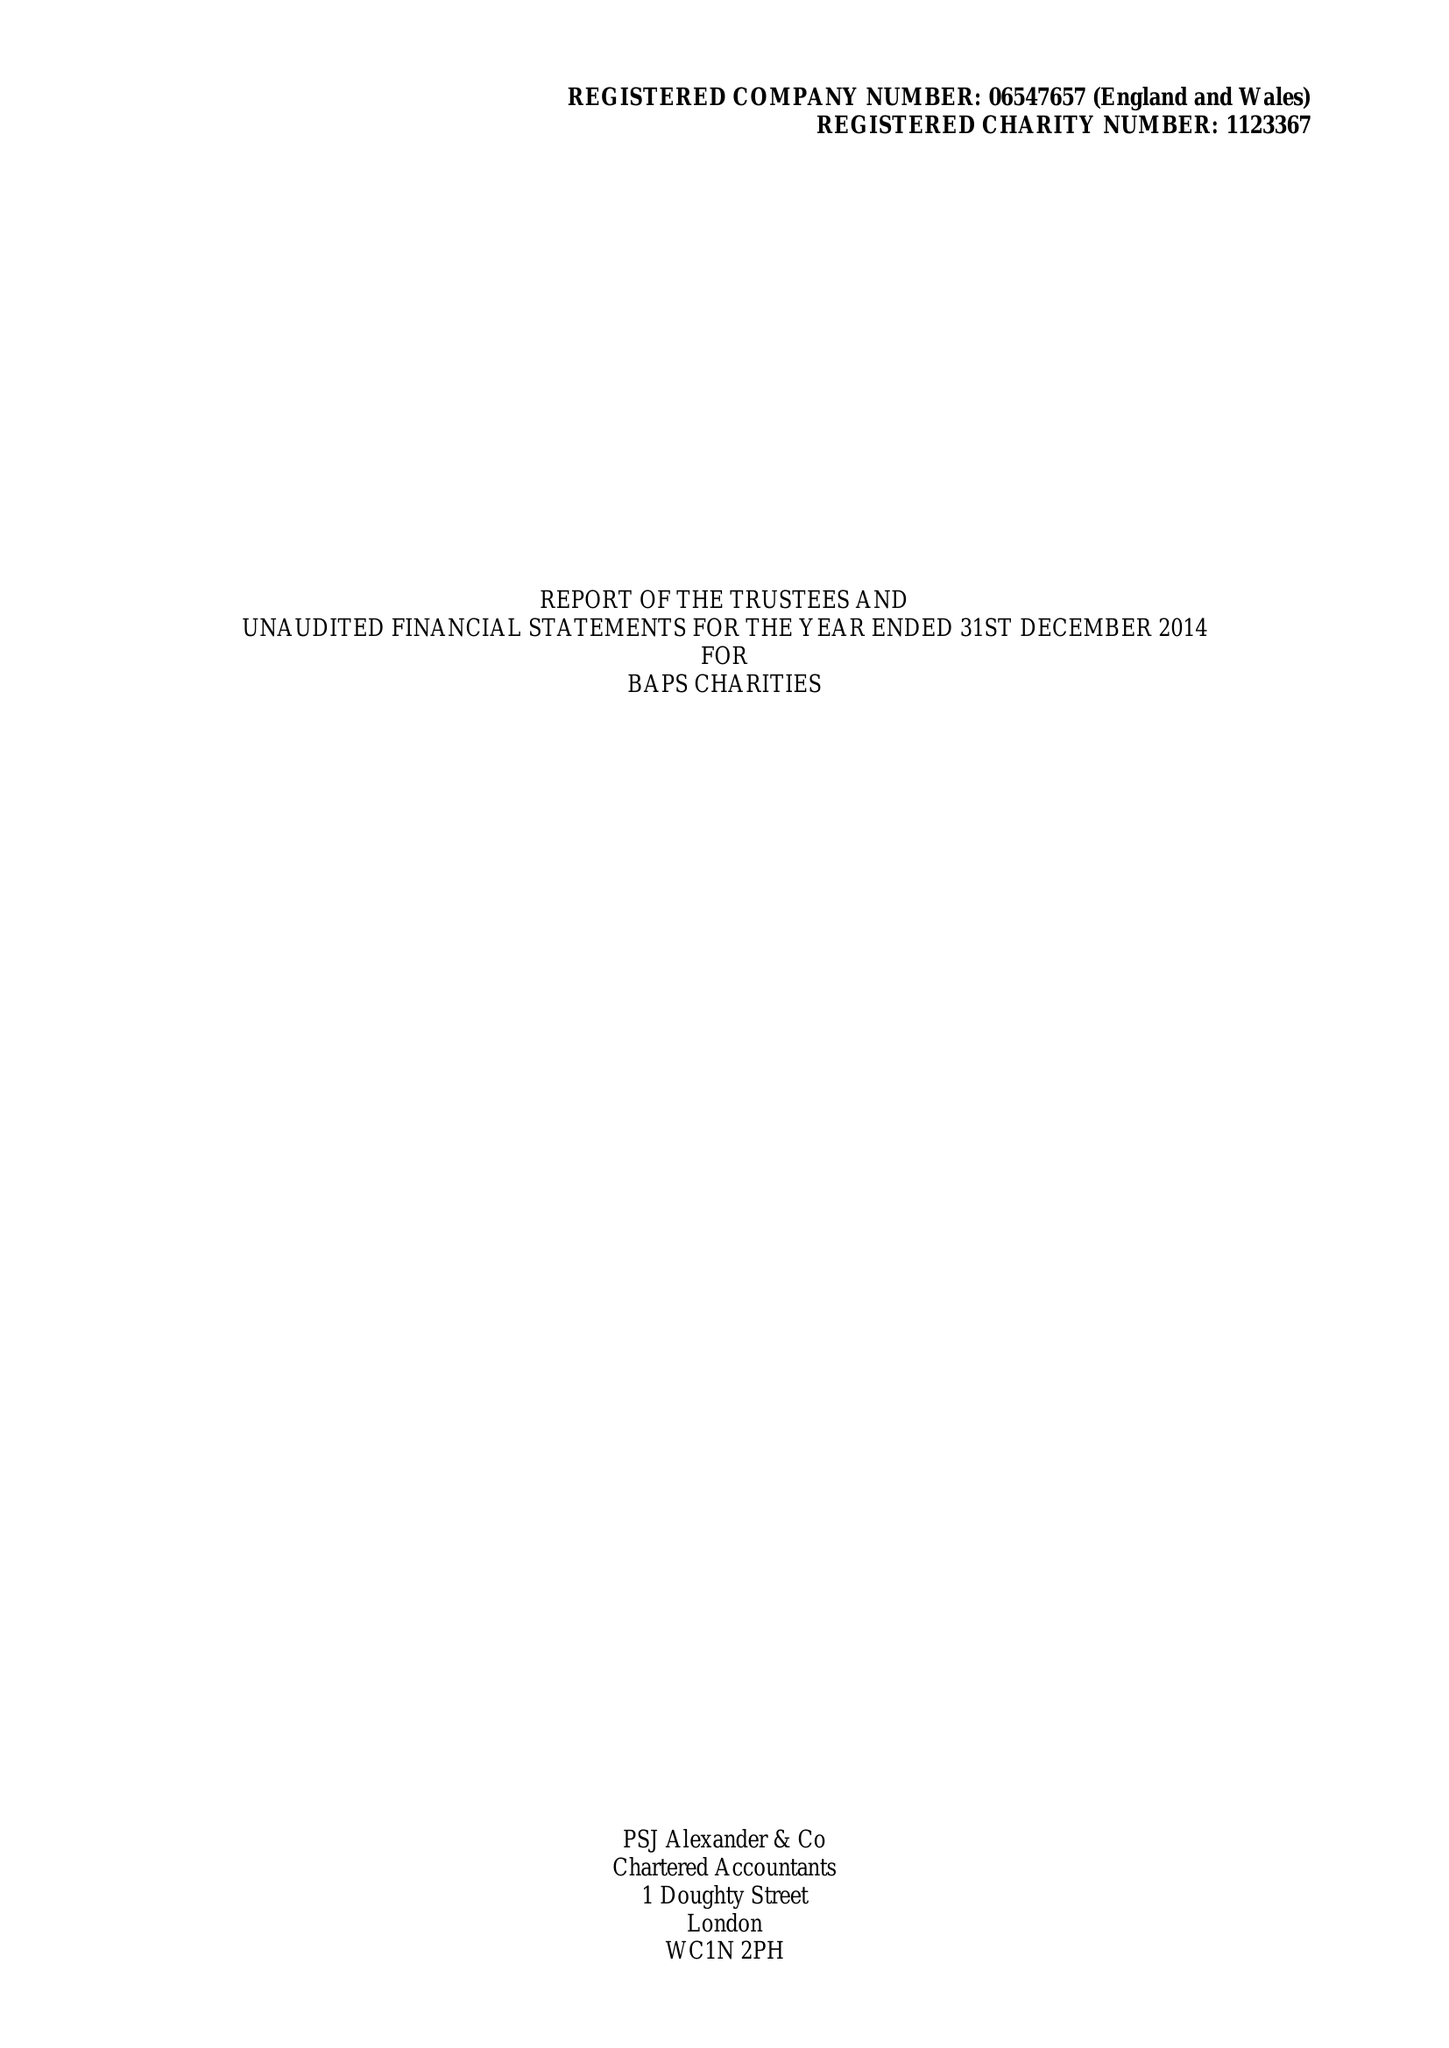What is the value for the charity_number?
Answer the question using a single word or phrase. 1123367 